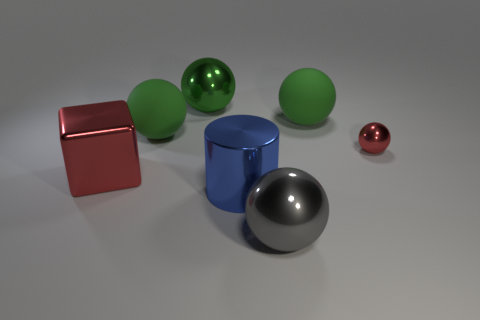Are there more tiny red spheres that are in front of the large red metallic cube than tiny blue metallic balls?
Give a very brief answer. No. What number of other things are there of the same size as the red metal block?
Ensure brevity in your answer.  5. What number of red metal things are both in front of the small sphere and to the right of the shiny block?
Ensure brevity in your answer.  0. Are the red object on the right side of the blue object and the large gray ball made of the same material?
Your answer should be compact. Yes. There is a large thing that is in front of the shiny cylinder that is left of the large matte ball to the right of the large gray metal ball; what is its shape?
Make the answer very short. Sphere. Are there the same number of large blue shiny cylinders that are behind the red cube and blue objects that are in front of the big gray sphere?
Offer a terse response. Yes. What is the color of the cylinder that is the same size as the gray ball?
Your answer should be compact. Blue. What number of large things are either red balls or rubber things?
Offer a terse response. 2. There is a thing that is both in front of the small red shiny ball and on the right side of the blue cylinder; what material is it?
Make the answer very short. Metal. Is the shape of the large shiny object in front of the big blue metallic object the same as the red shiny object in front of the tiny ball?
Provide a succinct answer. No. 